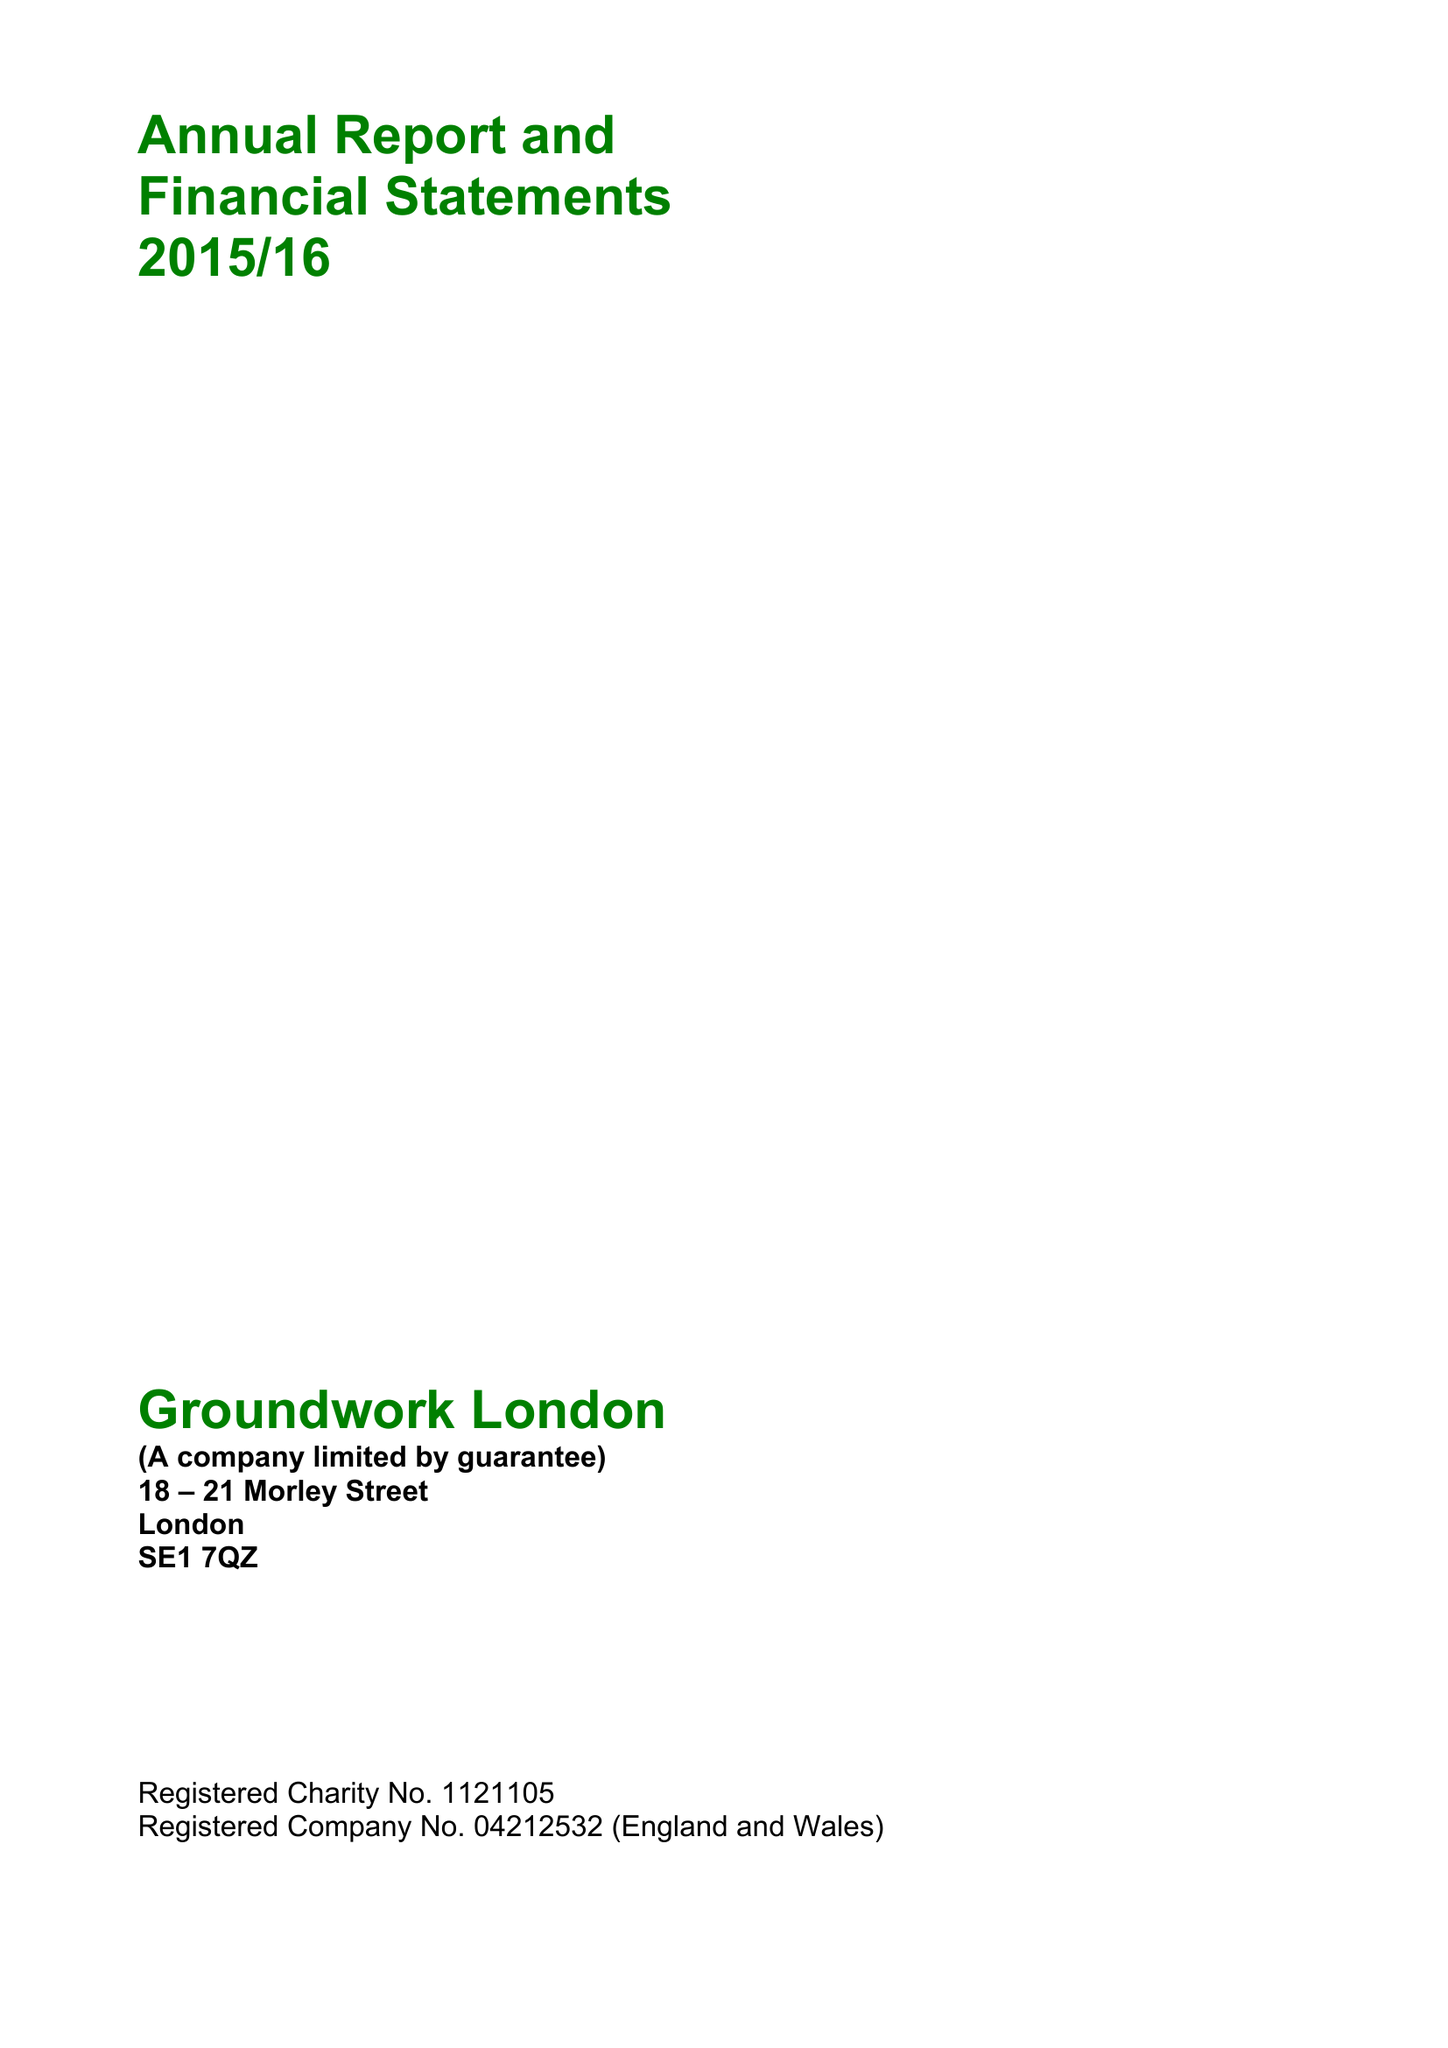What is the value for the charity_name?
Answer the question using a single word or phrase. Groundwork London 